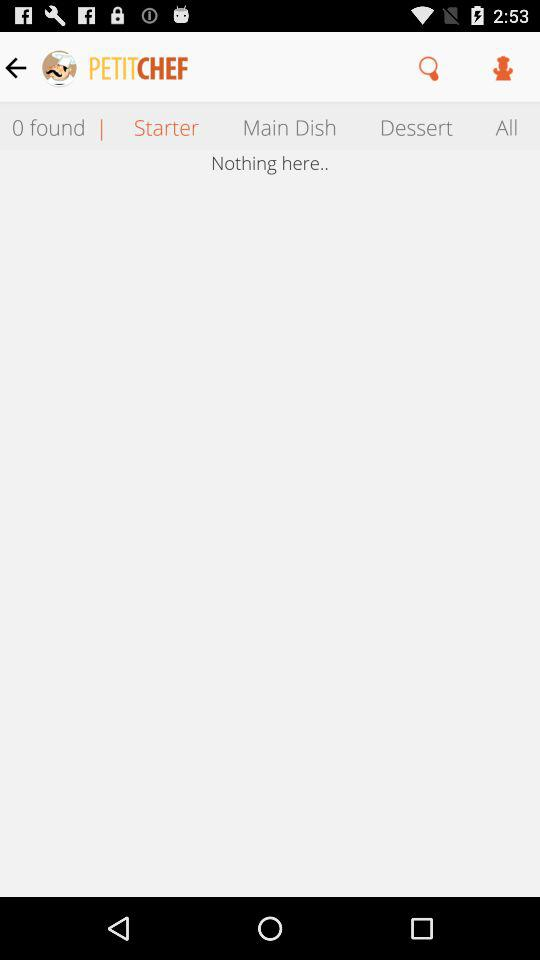Which entrees are selected in "Main Dish"?
When the provided information is insufficient, respond with <no answer>. <no answer> 